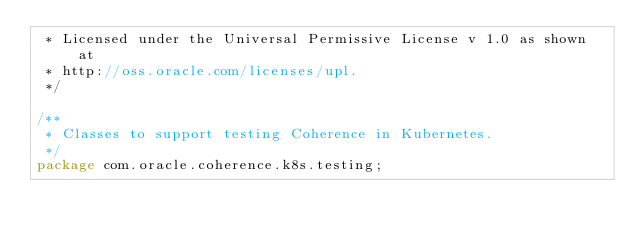Convert code to text. <code><loc_0><loc_0><loc_500><loc_500><_Java_> * Licensed under the Universal Permissive License v 1.0 as shown at
 * http://oss.oracle.com/licenses/upl.
 */

/**
 * Classes to support testing Coherence in Kubernetes.
 */
package com.oracle.coherence.k8s.testing;
</code> 